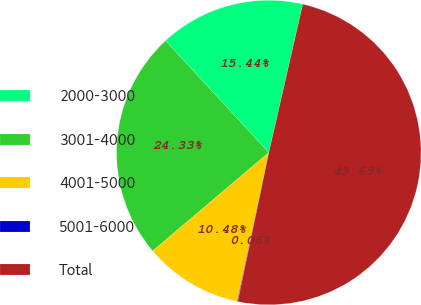Convert chart to OTSL. <chart><loc_0><loc_0><loc_500><loc_500><pie_chart><fcel>2000-3000<fcel>3001-4000<fcel>4001-5000<fcel>5001-6000<fcel>Total<nl><fcel>15.44%<fcel>24.33%<fcel>10.48%<fcel>0.06%<fcel>49.69%<nl></chart> 